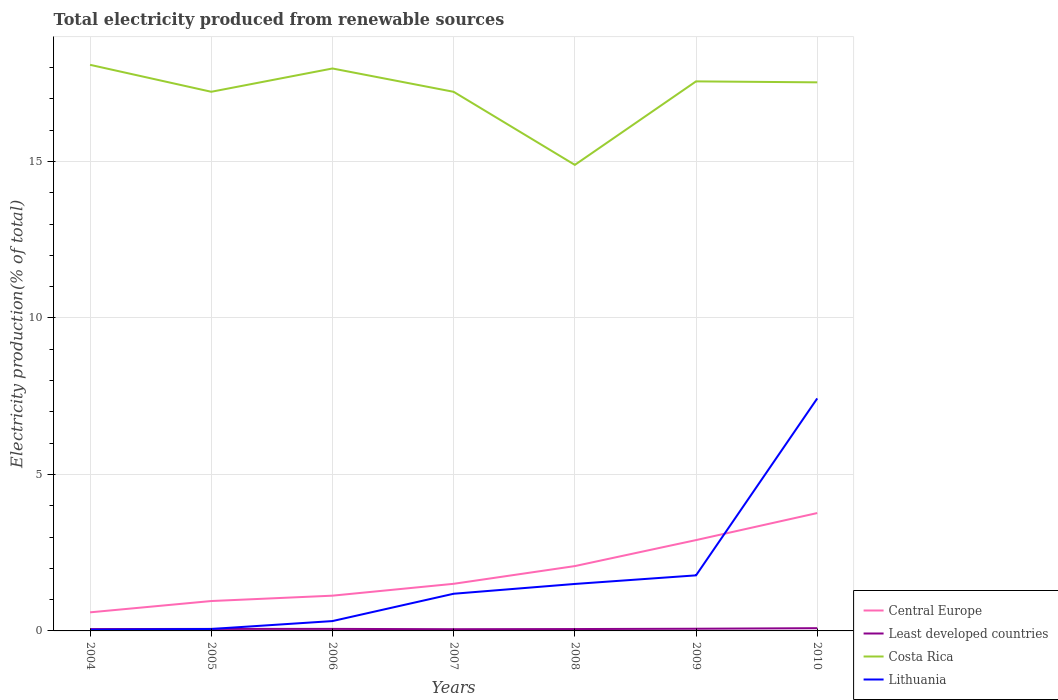How many different coloured lines are there?
Provide a succinct answer. 4. Across all years, what is the maximum total electricity produced in Lithuania?
Give a very brief answer. 0.04. In which year was the total electricity produced in Lithuania maximum?
Make the answer very short. 2004. What is the total total electricity produced in Lithuania in the graph?
Keep it short and to the point. -1.19. What is the difference between the highest and the second highest total electricity produced in Lithuania?
Keep it short and to the point. 7.39. What is the difference between the highest and the lowest total electricity produced in Least developed countries?
Your response must be concise. 2. How many lines are there?
Provide a succinct answer. 4. Are the values on the major ticks of Y-axis written in scientific E-notation?
Provide a short and direct response. No. Does the graph contain any zero values?
Offer a very short reply. No. Where does the legend appear in the graph?
Keep it short and to the point. Bottom right. How many legend labels are there?
Ensure brevity in your answer.  4. How are the legend labels stacked?
Offer a very short reply. Vertical. What is the title of the graph?
Provide a short and direct response. Total electricity produced from renewable sources. Does "Argentina" appear as one of the legend labels in the graph?
Offer a terse response. No. What is the label or title of the Y-axis?
Keep it short and to the point. Electricity production(% of total). What is the Electricity production(% of total) in Central Europe in 2004?
Make the answer very short. 0.59. What is the Electricity production(% of total) in Least developed countries in 2004?
Offer a very short reply. 0.06. What is the Electricity production(% of total) in Costa Rica in 2004?
Offer a terse response. 18.09. What is the Electricity production(% of total) in Lithuania in 2004?
Ensure brevity in your answer.  0.04. What is the Electricity production(% of total) in Central Europe in 2005?
Ensure brevity in your answer.  0.96. What is the Electricity production(% of total) in Least developed countries in 2005?
Give a very brief answer. 0.06. What is the Electricity production(% of total) in Costa Rica in 2005?
Offer a very short reply. 17.23. What is the Electricity production(% of total) in Lithuania in 2005?
Provide a succinct answer. 0.06. What is the Electricity production(% of total) in Central Europe in 2006?
Offer a terse response. 1.13. What is the Electricity production(% of total) of Least developed countries in 2006?
Your answer should be very brief. 0.06. What is the Electricity production(% of total) in Costa Rica in 2006?
Provide a short and direct response. 17.97. What is the Electricity production(% of total) in Lithuania in 2006?
Offer a terse response. 0.31. What is the Electricity production(% of total) of Central Europe in 2007?
Provide a short and direct response. 1.51. What is the Electricity production(% of total) of Least developed countries in 2007?
Your answer should be compact. 0.05. What is the Electricity production(% of total) in Costa Rica in 2007?
Give a very brief answer. 17.23. What is the Electricity production(% of total) in Lithuania in 2007?
Your response must be concise. 1.19. What is the Electricity production(% of total) in Central Europe in 2008?
Ensure brevity in your answer.  2.07. What is the Electricity production(% of total) of Least developed countries in 2008?
Provide a short and direct response. 0.06. What is the Electricity production(% of total) of Costa Rica in 2008?
Keep it short and to the point. 14.89. What is the Electricity production(% of total) in Lithuania in 2008?
Your response must be concise. 1.5. What is the Electricity production(% of total) of Central Europe in 2009?
Offer a very short reply. 2.9. What is the Electricity production(% of total) in Least developed countries in 2009?
Your answer should be compact. 0.07. What is the Electricity production(% of total) of Costa Rica in 2009?
Offer a terse response. 17.56. What is the Electricity production(% of total) in Lithuania in 2009?
Your answer should be compact. 1.78. What is the Electricity production(% of total) in Central Europe in 2010?
Make the answer very short. 3.77. What is the Electricity production(% of total) in Least developed countries in 2010?
Offer a terse response. 0.09. What is the Electricity production(% of total) of Costa Rica in 2010?
Your answer should be compact. 17.53. What is the Electricity production(% of total) in Lithuania in 2010?
Provide a short and direct response. 7.43. Across all years, what is the maximum Electricity production(% of total) in Central Europe?
Your response must be concise. 3.77. Across all years, what is the maximum Electricity production(% of total) in Least developed countries?
Keep it short and to the point. 0.09. Across all years, what is the maximum Electricity production(% of total) in Costa Rica?
Ensure brevity in your answer.  18.09. Across all years, what is the maximum Electricity production(% of total) of Lithuania?
Provide a succinct answer. 7.43. Across all years, what is the minimum Electricity production(% of total) in Central Europe?
Your response must be concise. 0.59. Across all years, what is the minimum Electricity production(% of total) in Least developed countries?
Ensure brevity in your answer.  0.05. Across all years, what is the minimum Electricity production(% of total) of Costa Rica?
Offer a terse response. 14.89. Across all years, what is the minimum Electricity production(% of total) of Lithuania?
Make the answer very short. 0.04. What is the total Electricity production(% of total) of Central Europe in the graph?
Make the answer very short. 12.92. What is the total Electricity production(% of total) of Least developed countries in the graph?
Your response must be concise. 0.46. What is the total Electricity production(% of total) in Costa Rica in the graph?
Your response must be concise. 120.5. What is the total Electricity production(% of total) of Lithuania in the graph?
Your answer should be very brief. 12.31. What is the difference between the Electricity production(% of total) of Central Europe in 2004 and that in 2005?
Make the answer very short. -0.36. What is the difference between the Electricity production(% of total) in Least developed countries in 2004 and that in 2005?
Make the answer very short. -0. What is the difference between the Electricity production(% of total) in Costa Rica in 2004 and that in 2005?
Make the answer very short. 0.86. What is the difference between the Electricity production(% of total) of Lithuania in 2004 and that in 2005?
Provide a short and direct response. -0.03. What is the difference between the Electricity production(% of total) of Central Europe in 2004 and that in 2006?
Offer a terse response. -0.53. What is the difference between the Electricity production(% of total) in Least developed countries in 2004 and that in 2006?
Provide a succinct answer. -0.01. What is the difference between the Electricity production(% of total) in Costa Rica in 2004 and that in 2006?
Provide a succinct answer. 0.12. What is the difference between the Electricity production(% of total) of Lithuania in 2004 and that in 2006?
Your answer should be compact. -0.28. What is the difference between the Electricity production(% of total) of Central Europe in 2004 and that in 2007?
Give a very brief answer. -0.91. What is the difference between the Electricity production(% of total) in Least developed countries in 2004 and that in 2007?
Provide a short and direct response. 0. What is the difference between the Electricity production(% of total) of Costa Rica in 2004 and that in 2007?
Your answer should be compact. 0.86. What is the difference between the Electricity production(% of total) of Lithuania in 2004 and that in 2007?
Keep it short and to the point. -1.15. What is the difference between the Electricity production(% of total) in Central Europe in 2004 and that in 2008?
Keep it short and to the point. -1.48. What is the difference between the Electricity production(% of total) in Least developed countries in 2004 and that in 2008?
Provide a succinct answer. -0. What is the difference between the Electricity production(% of total) of Costa Rica in 2004 and that in 2008?
Offer a very short reply. 3.2. What is the difference between the Electricity production(% of total) in Lithuania in 2004 and that in 2008?
Offer a terse response. -1.46. What is the difference between the Electricity production(% of total) of Central Europe in 2004 and that in 2009?
Provide a short and direct response. -2.31. What is the difference between the Electricity production(% of total) of Least developed countries in 2004 and that in 2009?
Offer a very short reply. -0.01. What is the difference between the Electricity production(% of total) in Costa Rica in 2004 and that in 2009?
Your answer should be very brief. 0.53. What is the difference between the Electricity production(% of total) of Lithuania in 2004 and that in 2009?
Offer a very short reply. -1.74. What is the difference between the Electricity production(% of total) in Central Europe in 2004 and that in 2010?
Your answer should be very brief. -3.17. What is the difference between the Electricity production(% of total) of Least developed countries in 2004 and that in 2010?
Your answer should be very brief. -0.03. What is the difference between the Electricity production(% of total) of Costa Rica in 2004 and that in 2010?
Offer a terse response. 0.56. What is the difference between the Electricity production(% of total) in Lithuania in 2004 and that in 2010?
Offer a very short reply. -7.39. What is the difference between the Electricity production(% of total) of Central Europe in 2005 and that in 2006?
Provide a succinct answer. -0.17. What is the difference between the Electricity production(% of total) of Least developed countries in 2005 and that in 2006?
Your answer should be compact. -0. What is the difference between the Electricity production(% of total) of Costa Rica in 2005 and that in 2006?
Offer a very short reply. -0.74. What is the difference between the Electricity production(% of total) of Lithuania in 2005 and that in 2006?
Provide a succinct answer. -0.25. What is the difference between the Electricity production(% of total) of Central Europe in 2005 and that in 2007?
Make the answer very short. -0.55. What is the difference between the Electricity production(% of total) of Least developed countries in 2005 and that in 2007?
Offer a terse response. 0.01. What is the difference between the Electricity production(% of total) of Costa Rica in 2005 and that in 2007?
Offer a terse response. 0. What is the difference between the Electricity production(% of total) in Lithuania in 2005 and that in 2007?
Your answer should be compact. -1.13. What is the difference between the Electricity production(% of total) of Central Europe in 2005 and that in 2008?
Make the answer very short. -1.12. What is the difference between the Electricity production(% of total) in Least developed countries in 2005 and that in 2008?
Offer a terse response. 0. What is the difference between the Electricity production(% of total) of Costa Rica in 2005 and that in 2008?
Make the answer very short. 2.34. What is the difference between the Electricity production(% of total) of Lithuania in 2005 and that in 2008?
Offer a terse response. -1.44. What is the difference between the Electricity production(% of total) of Central Europe in 2005 and that in 2009?
Your answer should be very brief. -1.95. What is the difference between the Electricity production(% of total) of Least developed countries in 2005 and that in 2009?
Your answer should be compact. -0.01. What is the difference between the Electricity production(% of total) of Costa Rica in 2005 and that in 2009?
Give a very brief answer. -0.33. What is the difference between the Electricity production(% of total) in Lithuania in 2005 and that in 2009?
Your answer should be compact. -1.71. What is the difference between the Electricity production(% of total) of Central Europe in 2005 and that in 2010?
Ensure brevity in your answer.  -2.81. What is the difference between the Electricity production(% of total) of Least developed countries in 2005 and that in 2010?
Make the answer very short. -0.02. What is the difference between the Electricity production(% of total) in Costa Rica in 2005 and that in 2010?
Offer a very short reply. -0.3. What is the difference between the Electricity production(% of total) in Lithuania in 2005 and that in 2010?
Offer a terse response. -7.37. What is the difference between the Electricity production(% of total) of Central Europe in 2006 and that in 2007?
Give a very brief answer. -0.38. What is the difference between the Electricity production(% of total) in Least developed countries in 2006 and that in 2007?
Make the answer very short. 0.01. What is the difference between the Electricity production(% of total) in Costa Rica in 2006 and that in 2007?
Ensure brevity in your answer.  0.75. What is the difference between the Electricity production(% of total) in Lithuania in 2006 and that in 2007?
Offer a terse response. -0.87. What is the difference between the Electricity production(% of total) in Central Europe in 2006 and that in 2008?
Offer a very short reply. -0.95. What is the difference between the Electricity production(% of total) in Least developed countries in 2006 and that in 2008?
Offer a very short reply. 0.01. What is the difference between the Electricity production(% of total) in Costa Rica in 2006 and that in 2008?
Your answer should be compact. 3.08. What is the difference between the Electricity production(% of total) in Lithuania in 2006 and that in 2008?
Your answer should be very brief. -1.19. What is the difference between the Electricity production(% of total) of Central Europe in 2006 and that in 2009?
Give a very brief answer. -1.78. What is the difference between the Electricity production(% of total) of Least developed countries in 2006 and that in 2009?
Offer a terse response. -0.01. What is the difference between the Electricity production(% of total) of Costa Rica in 2006 and that in 2009?
Give a very brief answer. 0.41. What is the difference between the Electricity production(% of total) in Lithuania in 2006 and that in 2009?
Ensure brevity in your answer.  -1.46. What is the difference between the Electricity production(% of total) in Central Europe in 2006 and that in 2010?
Your response must be concise. -2.64. What is the difference between the Electricity production(% of total) of Least developed countries in 2006 and that in 2010?
Your answer should be compact. -0.02. What is the difference between the Electricity production(% of total) of Costa Rica in 2006 and that in 2010?
Your answer should be compact. 0.44. What is the difference between the Electricity production(% of total) in Lithuania in 2006 and that in 2010?
Provide a succinct answer. -7.11. What is the difference between the Electricity production(% of total) of Central Europe in 2007 and that in 2008?
Provide a short and direct response. -0.57. What is the difference between the Electricity production(% of total) in Least developed countries in 2007 and that in 2008?
Your answer should be very brief. -0. What is the difference between the Electricity production(% of total) in Costa Rica in 2007 and that in 2008?
Keep it short and to the point. 2.33. What is the difference between the Electricity production(% of total) in Lithuania in 2007 and that in 2008?
Make the answer very short. -0.31. What is the difference between the Electricity production(% of total) in Central Europe in 2007 and that in 2009?
Offer a very short reply. -1.4. What is the difference between the Electricity production(% of total) in Least developed countries in 2007 and that in 2009?
Ensure brevity in your answer.  -0.01. What is the difference between the Electricity production(% of total) of Costa Rica in 2007 and that in 2009?
Keep it short and to the point. -0.33. What is the difference between the Electricity production(% of total) in Lithuania in 2007 and that in 2009?
Give a very brief answer. -0.59. What is the difference between the Electricity production(% of total) of Central Europe in 2007 and that in 2010?
Your response must be concise. -2.26. What is the difference between the Electricity production(% of total) of Least developed countries in 2007 and that in 2010?
Your answer should be compact. -0.03. What is the difference between the Electricity production(% of total) in Costa Rica in 2007 and that in 2010?
Provide a short and direct response. -0.3. What is the difference between the Electricity production(% of total) in Lithuania in 2007 and that in 2010?
Provide a succinct answer. -6.24. What is the difference between the Electricity production(% of total) in Central Europe in 2008 and that in 2009?
Provide a short and direct response. -0.83. What is the difference between the Electricity production(% of total) in Least developed countries in 2008 and that in 2009?
Provide a short and direct response. -0.01. What is the difference between the Electricity production(% of total) of Costa Rica in 2008 and that in 2009?
Offer a terse response. -2.67. What is the difference between the Electricity production(% of total) in Lithuania in 2008 and that in 2009?
Offer a very short reply. -0.27. What is the difference between the Electricity production(% of total) of Central Europe in 2008 and that in 2010?
Your answer should be compact. -1.69. What is the difference between the Electricity production(% of total) in Least developed countries in 2008 and that in 2010?
Ensure brevity in your answer.  -0.03. What is the difference between the Electricity production(% of total) of Costa Rica in 2008 and that in 2010?
Make the answer very short. -2.64. What is the difference between the Electricity production(% of total) of Lithuania in 2008 and that in 2010?
Your answer should be very brief. -5.93. What is the difference between the Electricity production(% of total) of Central Europe in 2009 and that in 2010?
Your answer should be compact. -0.86. What is the difference between the Electricity production(% of total) in Least developed countries in 2009 and that in 2010?
Offer a terse response. -0.02. What is the difference between the Electricity production(% of total) of Costa Rica in 2009 and that in 2010?
Your answer should be compact. 0.03. What is the difference between the Electricity production(% of total) in Lithuania in 2009 and that in 2010?
Your answer should be very brief. -5.65. What is the difference between the Electricity production(% of total) in Central Europe in 2004 and the Electricity production(% of total) in Least developed countries in 2005?
Your response must be concise. 0.53. What is the difference between the Electricity production(% of total) of Central Europe in 2004 and the Electricity production(% of total) of Costa Rica in 2005?
Make the answer very short. -16.63. What is the difference between the Electricity production(% of total) in Central Europe in 2004 and the Electricity production(% of total) in Lithuania in 2005?
Keep it short and to the point. 0.53. What is the difference between the Electricity production(% of total) of Least developed countries in 2004 and the Electricity production(% of total) of Costa Rica in 2005?
Offer a very short reply. -17.17. What is the difference between the Electricity production(% of total) of Least developed countries in 2004 and the Electricity production(% of total) of Lithuania in 2005?
Provide a short and direct response. -0. What is the difference between the Electricity production(% of total) in Costa Rica in 2004 and the Electricity production(% of total) in Lithuania in 2005?
Ensure brevity in your answer.  18.03. What is the difference between the Electricity production(% of total) in Central Europe in 2004 and the Electricity production(% of total) in Least developed countries in 2006?
Offer a very short reply. 0.53. What is the difference between the Electricity production(% of total) of Central Europe in 2004 and the Electricity production(% of total) of Costa Rica in 2006?
Provide a succinct answer. -17.38. What is the difference between the Electricity production(% of total) of Central Europe in 2004 and the Electricity production(% of total) of Lithuania in 2006?
Give a very brief answer. 0.28. What is the difference between the Electricity production(% of total) of Least developed countries in 2004 and the Electricity production(% of total) of Costa Rica in 2006?
Keep it short and to the point. -17.91. What is the difference between the Electricity production(% of total) of Least developed countries in 2004 and the Electricity production(% of total) of Lithuania in 2006?
Your answer should be compact. -0.26. What is the difference between the Electricity production(% of total) of Costa Rica in 2004 and the Electricity production(% of total) of Lithuania in 2006?
Keep it short and to the point. 17.77. What is the difference between the Electricity production(% of total) in Central Europe in 2004 and the Electricity production(% of total) in Least developed countries in 2007?
Give a very brief answer. 0.54. What is the difference between the Electricity production(% of total) of Central Europe in 2004 and the Electricity production(% of total) of Costa Rica in 2007?
Your answer should be compact. -16.63. What is the difference between the Electricity production(% of total) in Central Europe in 2004 and the Electricity production(% of total) in Lithuania in 2007?
Offer a terse response. -0.59. What is the difference between the Electricity production(% of total) in Least developed countries in 2004 and the Electricity production(% of total) in Costa Rica in 2007?
Keep it short and to the point. -17.17. What is the difference between the Electricity production(% of total) of Least developed countries in 2004 and the Electricity production(% of total) of Lithuania in 2007?
Provide a succinct answer. -1.13. What is the difference between the Electricity production(% of total) of Costa Rica in 2004 and the Electricity production(% of total) of Lithuania in 2007?
Give a very brief answer. 16.9. What is the difference between the Electricity production(% of total) of Central Europe in 2004 and the Electricity production(% of total) of Least developed countries in 2008?
Keep it short and to the point. 0.53. What is the difference between the Electricity production(% of total) in Central Europe in 2004 and the Electricity production(% of total) in Costa Rica in 2008?
Ensure brevity in your answer.  -14.3. What is the difference between the Electricity production(% of total) in Central Europe in 2004 and the Electricity production(% of total) in Lithuania in 2008?
Give a very brief answer. -0.91. What is the difference between the Electricity production(% of total) of Least developed countries in 2004 and the Electricity production(% of total) of Costa Rica in 2008?
Provide a succinct answer. -14.83. What is the difference between the Electricity production(% of total) of Least developed countries in 2004 and the Electricity production(% of total) of Lithuania in 2008?
Offer a terse response. -1.44. What is the difference between the Electricity production(% of total) of Costa Rica in 2004 and the Electricity production(% of total) of Lithuania in 2008?
Provide a short and direct response. 16.59. What is the difference between the Electricity production(% of total) in Central Europe in 2004 and the Electricity production(% of total) in Least developed countries in 2009?
Offer a very short reply. 0.52. What is the difference between the Electricity production(% of total) in Central Europe in 2004 and the Electricity production(% of total) in Costa Rica in 2009?
Give a very brief answer. -16.97. What is the difference between the Electricity production(% of total) in Central Europe in 2004 and the Electricity production(% of total) in Lithuania in 2009?
Give a very brief answer. -1.18. What is the difference between the Electricity production(% of total) of Least developed countries in 2004 and the Electricity production(% of total) of Costa Rica in 2009?
Keep it short and to the point. -17.5. What is the difference between the Electricity production(% of total) in Least developed countries in 2004 and the Electricity production(% of total) in Lithuania in 2009?
Your answer should be compact. -1.72. What is the difference between the Electricity production(% of total) of Costa Rica in 2004 and the Electricity production(% of total) of Lithuania in 2009?
Offer a terse response. 16.31. What is the difference between the Electricity production(% of total) in Central Europe in 2004 and the Electricity production(% of total) in Least developed countries in 2010?
Provide a succinct answer. 0.51. What is the difference between the Electricity production(% of total) of Central Europe in 2004 and the Electricity production(% of total) of Costa Rica in 2010?
Provide a succinct answer. -16.94. What is the difference between the Electricity production(% of total) of Central Europe in 2004 and the Electricity production(% of total) of Lithuania in 2010?
Give a very brief answer. -6.83. What is the difference between the Electricity production(% of total) in Least developed countries in 2004 and the Electricity production(% of total) in Costa Rica in 2010?
Offer a very short reply. -17.47. What is the difference between the Electricity production(% of total) of Least developed countries in 2004 and the Electricity production(% of total) of Lithuania in 2010?
Keep it short and to the point. -7.37. What is the difference between the Electricity production(% of total) in Costa Rica in 2004 and the Electricity production(% of total) in Lithuania in 2010?
Provide a short and direct response. 10.66. What is the difference between the Electricity production(% of total) in Central Europe in 2005 and the Electricity production(% of total) in Least developed countries in 2006?
Keep it short and to the point. 0.89. What is the difference between the Electricity production(% of total) in Central Europe in 2005 and the Electricity production(% of total) in Costa Rica in 2006?
Your response must be concise. -17.02. What is the difference between the Electricity production(% of total) of Central Europe in 2005 and the Electricity production(% of total) of Lithuania in 2006?
Offer a terse response. 0.64. What is the difference between the Electricity production(% of total) in Least developed countries in 2005 and the Electricity production(% of total) in Costa Rica in 2006?
Your answer should be very brief. -17.91. What is the difference between the Electricity production(% of total) in Least developed countries in 2005 and the Electricity production(% of total) in Lithuania in 2006?
Offer a very short reply. -0.25. What is the difference between the Electricity production(% of total) in Costa Rica in 2005 and the Electricity production(% of total) in Lithuania in 2006?
Your response must be concise. 16.91. What is the difference between the Electricity production(% of total) in Central Europe in 2005 and the Electricity production(% of total) in Least developed countries in 2007?
Give a very brief answer. 0.9. What is the difference between the Electricity production(% of total) in Central Europe in 2005 and the Electricity production(% of total) in Costa Rica in 2007?
Your answer should be compact. -16.27. What is the difference between the Electricity production(% of total) in Central Europe in 2005 and the Electricity production(% of total) in Lithuania in 2007?
Give a very brief answer. -0.23. What is the difference between the Electricity production(% of total) of Least developed countries in 2005 and the Electricity production(% of total) of Costa Rica in 2007?
Offer a very short reply. -17.16. What is the difference between the Electricity production(% of total) in Least developed countries in 2005 and the Electricity production(% of total) in Lithuania in 2007?
Provide a succinct answer. -1.12. What is the difference between the Electricity production(% of total) in Costa Rica in 2005 and the Electricity production(% of total) in Lithuania in 2007?
Keep it short and to the point. 16.04. What is the difference between the Electricity production(% of total) in Central Europe in 2005 and the Electricity production(% of total) in Least developed countries in 2008?
Ensure brevity in your answer.  0.9. What is the difference between the Electricity production(% of total) in Central Europe in 2005 and the Electricity production(% of total) in Costa Rica in 2008?
Provide a succinct answer. -13.94. What is the difference between the Electricity production(% of total) of Central Europe in 2005 and the Electricity production(% of total) of Lithuania in 2008?
Offer a very short reply. -0.55. What is the difference between the Electricity production(% of total) in Least developed countries in 2005 and the Electricity production(% of total) in Costa Rica in 2008?
Your answer should be compact. -14.83. What is the difference between the Electricity production(% of total) of Least developed countries in 2005 and the Electricity production(% of total) of Lithuania in 2008?
Offer a terse response. -1.44. What is the difference between the Electricity production(% of total) in Costa Rica in 2005 and the Electricity production(% of total) in Lithuania in 2008?
Make the answer very short. 15.73. What is the difference between the Electricity production(% of total) in Central Europe in 2005 and the Electricity production(% of total) in Least developed countries in 2009?
Give a very brief answer. 0.89. What is the difference between the Electricity production(% of total) of Central Europe in 2005 and the Electricity production(% of total) of Costa Rica in 2009?
Make the answer very short. -16.6. What is the difference between the Electricity production(% of total) in Central Europe in 2005 and the Electricity production(% of total) in Lithuania in 2009?
Make the answer very short. -0.82. What is the difference between the Electricity production(% of total) of Least developed countries in 2005 and the Electricity production(% of total) of Costa Rica in 2009?
Provide a succinct answer. -17.5. What is the difference between the Electricity production(% of total) of Least developed countries in 2005 and the Electricity production(% of total) of Lithuania in 2009?
Ensure brevity in your answer.  -1.71. What is the difference between the Electricity production(% of total) of Costa Rica in 2005 and the Electricity production(% of total) of Lithuania in 2009?
Keep it short and to the point. 15.45. What is the difference between the Electricity production(% of total) in Central Europe in 2005 and the Electricity production(% of total) in Least developed countries in 2010?
Your response must be concise. 0.87. What is the difference between the Electricity production(% of total) in Central Europe in 2005 and the Electricity production(% of total) in Costa Rica in 2010?
Your answer should be very brief. -16.57. What is the difference between the Electricity production(% of total) in Central Europe in 2005 and the Electricity production(% of total) in Lithuania in 2010?
Provide a short and direct response. -6.47. What is the difference between the Electricity production(% of total) of Least developed countries in 2005 and the Electricity production(% of total) of Costa Rica in 2010?
Make the answer very short. -17.47. What is the difference between the Electricity production(% of total) in Least developed countries in 2005 and the Electricity production(% of total) in Lithuania in 2010?
Your answer should be very brief. -7.37. What is the difference between the Electricity production(% of total) of Costa Rica in 2005 and the Electricity production(% of total) of Lithuania in 2010?
Ensure brevity in your answer.  9.8. What is the difference between the Electricity production(% of total) of Central Europe in 2006 and the Electricity production(% of total) of Least developed countries in 2007?
Ensure brevity in your answer.  1.07. What is the difference between the Electricity production(% of total) of Central Europe in 2006 and the Electricity production(% of total) of Costa Rica in 2007?
Offer a terse response. -16.1. What is the difference between the Electricity production(% of total) in Central Europe in 2006 and the Electricity production(% of total) in Lithuania in 2007?
Keep it short and to the point. -0.06. What is the difference between the Electricity production(% of total) of Least developed countries in 2006 and the Electricity production(% of total) of Costa Rica in 2007?
Your answer should be compact. -17.16. What is the difference between the Electricity production(% of total) of Least developed countries in 2006 and the Electricity production(% of total) of Lithuania in 2007?
Give a very brief answer. -1.12. What is the difference between the Electricity production(% of total) of Costa Rica in 2006 and the Electricity production(% of total) of Lithuania in 2007?
Ensure brevity in your answer.  16.78. What is the difference between the Electricity production(% of total) of Central Europe in 2006 and the Electricity production(% of total) of Least developed countries in 2008?
Your answer should be compact. 1.07. What is the difference between the Electricity production(% of total) of Central Europe in 2006 and the Electricity production(% of total) of Costa Rica in 2008?
Offer a very short reply. -13.77. What is the difference between the Electricity production(% of total) in Central Europe in 2006 and the Electricity production(% of total) in Lithuania in 2008?
Your answer should be very brief. -0.37. What is the difference between the Electricity production(% of total) in Least developed countries in 2006 and the Electricity production(% of total) in Costa Rica in 2008?
Your answer should be compact. -14.83. What is the difference between the Electricity production(% of total) in Least developed countries in 2006 and the Electricity production(% of total) in Lithuania in 2008?
Give a very brief answer. -1.44. What is the difference between the Electricity production(% of total) in Costa Rica in 2006 and the Electricity production(% of total) in Lithuania in 2008?
Your answer should be compact. 16.47. What is the difference between the Electricity production(% of total) of Central Europe in 2006 and the Electricity production(% of total) of Least developed countries in 2009?
Keep it short and to the point. 1.06. What is the difference between the Electricity production(% of total) of Central Europe in 2006 and the Electricity production(% of total) of Costa Rica in 2009?
Provide a short and direct response. -16.43. What is the difference between the Electricity production(% of total) of Central Europe in 2006 and the Electricity production(% of total) of Lithuania in 2009?
Your answer should be very brief. -0.65. What is the difference between the Electricity production(% of total) of Least developed countries in 2006 and the Electricity production(% of total) of Costa Rica in 2009?
Provide a succinct answer. -17.5. What is the difference between the Electricity production(% of total) of Least developed countries in 2006 and the Electricity production(% of total) of Lithuania in 2009?
Your answer should be compact. -1.71. What is the difference between the Electricity production(% of total) of Costa Rica in 2006 and the Electricity production(% of total) of Lithuania in 2009?
Make the answer very short. 16.2. What is the difference between the Electricity production(% of total) in Central Europe in 2006 and the Electricity production(% of total) in Least developed countries in 2010?
Ensure brevity in your answer.  1.04. What is the difference between the Electricity production(% of total) in Central Europe in 2006 and the Electricity production(% of total) in Costa Rica in 2010?
Offer a terse response. -16.4. What is the difference between the Electricity production(% of total) of Central Europe in 2006 and the Electricity production(% of total) of Lithuania in 2010?
Your answer should be compact. -6.3. What is the difference between the Electricity production(% of total) of Least developed countries in 2006 and the Electricity production(% of total) of Costa Rica in 2010?
Keep it short and to the point. -17.46. What is the difference between the Electricity production(% of total) in Least developed countries in 2006 and the Electricity production(% of total) in Lithuania in 2010?
Your response must be concise. -7.36. What is the difference between the Electricity production(% of total) in Costa Rica in 2006 and the Electricity production(% of total) in Lithuania in 2010?
Keep it short and to the point. 10.54. What is the difference between the Electricity production(% of total) of Central Europe in 2007 and the Electricity production(% of total) of Least developed countries in 2008?
Keep it short and to the point. 1.45. What is the difference between the Electricity production(% of total) of Central Europe in 2007 and the Electricity production(% of total) of Costa Rica in 2008?
Your response must be concise. -13.39. What is the difference between the Electricity production(% of total) in Central Europe in 2007 and the Electricity production(% of total) in Lithuania in 2008?
Provide a succinct answer. 0. What is the difference between the Electricity production(% of total) in Least developed countries in 2007 and the Electricity production(% of total) in Costa Rica in 2008?
Your response must be concise. -14.84. What is the difference between the Electricity production(% of total) in Least developed countries in 2007 and the Electricity production(% of total) in Lithuania in 2008?
Provide a short and direct response. -1.45. What is the difference between the Electricity production(% of total) of Costa Rica in 2007 and the Electricity production(% of total) of Lithuania in 2008?
Give a very brief answer. 15.73. What is the difference between the Electricity production(% of total) in Central Europe in 2007 and the Electricity production(% of total) in Least developed countries in 2009?
Your response must be concise. 1.44. What is the difference between the Electricity production(% of total) in Central Europe in 2007 and the Electricity production(% of total) in Costa Rica in 2009?
Ensure brevity in your answer.  -16.05. What is the difference between the Electricity production(% of total) of Central Europe in 2007 and the Electricity production(% of total) of Lithuania in 2009?
Give a very brief answer. -0.27. What is the difference between the Electricity production(% of total) of Least developed countries in 2007 and the Electricity production(% of total) of Costa Rica in 2009?
Give a very brief answer. -17.5. What is the difference between the Electricity production(% of total) of Least developed countries in 2007 and the Electricity production(% of total) of Lithuania in 2009?
Your answer should be very brief. -1.72. What is the difference between the Electricity production(% of total) in Costa Rica in 2007 and the Electricity production(% of total) in Lithuania in 2009?
Your answer should be compact. 15.45. What is the difference between the Electricity production(% of total) in Central Europe in 2007 and the Electricity production(% of total) in Least developed countries in 2010?
Make the answer very short. 1.42. What is the difference between the Electricity production(% of total) in Central Europe in 2007 and the Electricity production(% of total) in Costa Rica in 2010?
Keep it short and to the point. -16.02. What is the difference between the Electricity production(% of total) in Central Europe in 2007 and the Electricity production(% of total) in Lithuania in 2010?
Offer a terse response. -5.92. What is the difference between the Electricity production(% of total) in Least developed countries in 2007 and the Electricity production(% of total) in Costa Rica in 2010?
Give a very brief answer. -17.47. What is the difference between the Electricity production(% of total) of Least developed countries in 2007 and the Electricity production(% of total) of Lithuania in 2010?
Provide a succinct answer. -7.37. What is the difference between the Electricity production(% of total) of Costa Rica in 2007 and the Electricity production(% of total) of Lithuania in 2010?
Your answer should be very brief. 9.8. What is the difference between the Electricity production(% of total) of Central Europe in 2008 and the Electricity production(% of total) of Least developed countries in 2009?
Make the answer very short. 2. What is the difference between the Electricity production(% of total) of Central Europe in 2008 and the Electricity production(% of total) of Costa Rica in 2009?
Ensure brevity in your answer.  -15.49. What is the difference between the Electricity production(% of total) of Central Europe in 2008 and the Electricity production(% of total) of Lithuania in 2009?
Offer a very short reply. 0.3. What is the difference between the Electricity production(% of total) of Least developed countries in 2008 and the Electricity production(% of total) of Costa Rica in 2009?
Provide a short and direct response. -17.5. What is the difference between the Electricity production(% of total) of Least developed countries in 2008 and the Electricity production(% of total) of Lithuania in 2009?
Your response must be concise. -1.72. What is the difference between the Electricity production(% of total) of Costa Rica in 2008 and the Electricity production(% of total) of Lithuania in 2009?
Your response must be concise. 13.12. What is the difference between the Electricity production(% of total) in Central Europe in 2008 and the Electricity production(% of total) in Least developed countries in 2010?
Provide a short and direct response. 1.98. What is the difference between the Electricity production(% of total) of Central Europe in 2008 and the Electricity production(% of total) of Costa Rica in 2010?
Make the answer very short. -15.46. What is the difference between the Electricity production(% of total) of Central Europe in 2008 and the Electricity production(% of total) of Lithuania in 2010?
Your answer should be very brief. -5.36. What is the difference between the Electricity production(% of total) in Least developed countries in 2008 and the Electricity production(% of total) in Costa Rica in 2010?
Ensure brevity in your answer.  -17.47. What is the difference between the Electricity production(% of total) of Least developed countries in 2008 and the Electricity production(% of total) of Lithuania in 2010?
Give a very brief answer. -7.37. What is the difference between the Electricity production(% of total) in Costa Rica in 2008 and the Electricity production(% of total) in Lithuania in 2010?
Offer a terse response. 7.46. What is the difference between the Electricity production(% of total) of Central Europe in 2009 and the Electricity production(% of total) of Least developed countries in 2010?
Your answer should be compact. 2.82. What is the difference between the Electricity production(% of total) of Central Europe in 2009 and the Electricity production(% of total) of Costa Rica in 2010?
Your answer should be very brief. -14.63. What is the difference between the Electricity production(% of total) of Central Europe in 2009 and the Electricity production(% of total) of Lithuania in 2010?
Your answer should be compact. -4.53. What is the difference between the Electricity production(% of total) of Least developed countries in 2009 and the Electricity production(% of total) of Costa Rica in 2010?
Your answer should be compact. -17.46. What is the difference between the Electricity production(% of total) of Least developed countries in 2009 and the Electricity production(% of total) of Lithuania in 2010?
Offer a terse response. -7.36. What is the difference between the Electricity production(% of total) in Costa Rica in 2009 and the Electricity production(% of total) in Lithuania in 2010?
Keep it short and to the point. 10.13. What is the average Electricity production(% of total) in Central Europe per year?
Give a very brief answer. 1.85. What is the average Electricity production(% of total) of Least developed countries per year?
Offer a terse response. 0.07. What is the average Electricity production(% of total) in Costa Rica per year?
Your answer should be compact. 17.21. What is the average Electricity production(% of total) in Lithuania per year?
Ensure brevity in your answer.  1.76. In the year 2004, what is the difference between the Electricity production(% of total) in Central Europe and Electricity production(% of total) in Least developed countries?
Your response must be concise. 0.54. In the year 2004, what is the difference between the Electricity production(% of total) in Central Europe and Electricity production(% of total) in Costa Rica?
Ensure brevity in your answer.  -17.5. In the year 2004, what is the difference between the Electricity production(% of total) in Central Europe and Electricity production(% of total) in Lithuania?
Provide a succinct answer. 0.56. In the year 2004, what is the difference between the Electricity production(% of total) of Least developed countries and Electricity production(% of total) of Costa Rica?
Offer a terse response. -18.03. In the year 2004, what is the difference between the Electricity production(% of total) in Least developed countries and Electricity production(% of total) in Lithuania?
Your response must be concise. 0.02. In the year 2004, what is the difference between the Electricity production(% of total) of Costa Rica and Electricity production(% of total) of Lithuania?
Provide a short and direct response. 18.05. In the year 2005, what is the difference between the Electricity production(% of total) in Central Europe and Electricity production(% of total) in Least developed countries?
Keep it short and to the point. 0.89. In the year 2005, what is the difference between the Electricity production(% of total) of Central Europe and Electricity production(% of total) of Costa Rica?
Provide a short and direct response. -16.27. In the year 2005, what is the difference between the Electricity production(% of total) in Central Europe and Electricity production(% of total) in Lithuania?
Your answer should be very brief. 0.89. In the year 2005, what is the difference between the Electricity production(% of total) in Least developed countries and Electricity production(% of total) in Costa Rica?
Offer a terse response. -17.16. In the year 2005, what is the difference between the Electricity production(% of total) in Least developed countries and Electricity production(% of total) in Lithuania?
Your answer should be very brief. 0. In the year 2005, what is the difference between the Electricity production(% of total) of Costa Rica and Electricity production(% of total) of Lithuania?
Your response must be concise. 17.17. In the year 2006, what is the difference between the Electricity production(% of total) in Central Europe and Electricity production(% of total) in Least developed countries?
Your response must be concise. 1.06. In the year 2006, what is the difference between the Electricity production(% of total) of Central Europe and Electricity production(% of total) of Costa Rica?
Your answer should be very brief. -16.85. In the year 2006, what is the difference between the Electricity production(% of total) in Central Europe and Electricity production(% of total) in Lithuania?
Your answer should be very brief. 0.81. In the year 2006, what is the difference between the Electricity production(% of total) of Least developed countries and Electricity production(% of total) of Costa Rica?
Your response must be concise. -17.91. In the year 2006, what is the difference between the Electricity production(% of total) in Least developed countries and Electricity production(% of total) in Lithuania?
Provide a succinct answer. -0.25. In the year 2006, what is the difference between the Electricity production(% of total) of Costa Rica and Electricity production(% of total) of Lithuania?
Ensure brevity in your answer.  17.66. In the year 2007, what is the difference between the Electricity production(% of total) in Central Europe and Electricity production(% of total) in Least developed countries?
Give a very brief answer. 1.45. In the year 2007, what is the difference between the Electricity production(% of total) of Central Europe and Electricity production(% of total) of Costa Rica?
Provide a short and direct response. -15.72. In the year 2007, what is the difference between the Electricity production(% of total) in Central Europe and Electricity production(% of total) in Lithuania?
Your answer should be very brief. 0.32. In the year 2007, what is the difference between the Electricity production(% of total) of Least developed countries and Electricity production(% of total) of Costa Rica?
Your answer should be very brief. -17.17. In the year 2007, what is the difference between the Electricity production(% of total) in Least developed countries and Electricity production(% of total) in Lithuania?
Your answer should be compact. -1.13. In the year 2007, what is the difference between the Electricity production(% of total) of Costa Rica and Electricity production(% of total) of Lithuania?
Your answer should be compact. 16.04. In the year 2008, what is the difference between the Electricity production(% of total) of Central Europe and Electricity production(% of total) of Least developed countries?
Your answer should be very brief. 2.01. In the year 2008, what is the difference between the Electricity production(% of total) of Central Europe and Electricity production(% of total) of Costa Rica?
Ensure brevity in your answer.  -12.82. In the year 2008, what is the difference between the Electricity production(% of total) of Central Europe and Electricity production(% of total) of Lithuania?
Keep it short and to the point. 0.57. In the year 2008, what is the difference between the Electricity production(% of total) of Least developed countries and Electricity production(% of total) of Costa Rica?
Offer a very short reply. -14.83. In the year 2008, what is the difference between the Electricity production(% of total) of Least developed countries and Electricity production(% of total) of Lithuania?
Your response must be concise. -1.44. In the year 2008, what is the difference between the Electricity production(% of total) of Costa Rica and Electricity production(% of total) of Lithuania?
Offer a very short reply. 13.39. In the year 2009, what is the difference between the Electricity production(% of total) in Central Europe and Electricity production(% of total) in Least developed countries?
Your answer should be compact. 2.83. In the year 2009, what is the difference between the Electricity production(% of total) in Central Europe and Electricity production(% of total) in Costa Rica?
Make the answer very short. -14.66. In the year 2009, what is the difference between the Electricity production(% of total) in Central Europe and Electricity production(% of total) in Lithuania?
Provide a short and direct response. 1.13. In the year 2009, what is the difference between the Electricity production(% of total) in Least developed countries and Electricity production(% of total) in Costa Rica?
Offer a terse response. -17.49. In the year 2009, what is the difference between the Electricity production(% of total) of Least developed countries and Electricity production(% of total) of Lithuania?
Your response must be concise. -1.71. In the year 2009, what is the difference between the Electricity production(% of total) of Costa Rica and Electricity production(% of total) of Lithuania?
Your answer should be compact. 15.78. In the year 2010, what is the difference between the Electricity production(% of total) of Central Europe and Electricity production(% of total) of Least developed countries?
Offer a very short reply. 3.68. In the year 2010, what is the difference between the Electricity production(% of total) in Central Europe and Electricity production(% of total) in Costa Rica?
Give a very brief answer. -13.76. In the year 2010, what is the difference between the Electricity production(% of total) of Central Europe and Electricity production(% of total) of Lithuania?
Offer a terse response. -3.66. In the year 2010, what is the difference between the Electricity production(% of total) in Least developed countries and Electricity production(% of total) in Costa Rica?
Ensure brevity in your answer.  -17.44. In the year 2010, what is the difference between the Electricity production(% of total) of Least developed countries and Electricity production(% of total) of Lithuania?
Provide a succinct answer. -7.34. In the year 2010, what is the difference between the Electricity production(% of total) of Costa Rica and Electricity production(% of total) of Lithuania?
Make the answer very short. 10.1. What is the ratio of the Electricity production(% of total) in Central Europe in 2004 to that in 2005?
Ensure brevity in your answer.  0.62. What is the ratio of the Electricity production(% of total) of Least developed countries in 2004 to that in 2005?
Keep it short and to the point. 0.92. What is the ratio of the Electricity production(% of total) of Lithuania in 2004 to that in 2005?
Provide a succinct answer. 0.6. What is the ratio of the Electricity production(% of total) of Central Europe in 2004 to that in 2006?
Give a very brief answer. 0.53. What is the ratio of the Electricity production(% of total) in Least developed countries in 2004 to that in 2006?
Give a very brief answer. 0.91. What is the ratio of the Electricity production(% of total) in Lithuania in 2004 to that in 2006?
Keep it short and to the point. 0.12. What is the ratio of the Electricity production(% of total) of Central Europe in 2004 to that in 2007?
Offer a very short reply. 0.39. What is the ratio of the Electricity production(% of total) of Least developed countries in 2004 to that in 2007?
Make the answer very short. 1.07. What is the ratio of the Electricity production(% of total) of Costa Rica in 2004 to that in 2007?
Your response must be concise. 1.05. What is the ratio of the Electricity production(% of total) in Lithuania in 2004 to that in 2007?
Ensure brevity in your answer.  0.03. What is the ratio of the Electricity production(% of total) in Central Europe in 2004 to that in 2008?
Give a very brief answer. 0.29. What is the ratio of the Electricity production(% of total) in Least developed countries in 2004 to that in 2008?
Provide a succinct answer. 0.99. What is the ratio of the Electricity production(% of total) in Costa Rica in 2004 to that in 2008?
Make the answer very short. 1.21. What is the ratio of the Electricity production(% of total) of Lithuania in 2004 to that in 2008?
Your answer should be very brief. 0.02. What is the ratio of the Electricity production(% of total) of Central Europe in 2004 to that in 2009?
Ensure brevity in your answer.  0.2. What is the ratio of the Electricity production(% of total) of Least developed countries in 2004 to that in 2009?
Your answer should be very brief. 0.84. What is the ratio of the Electricity production(% of total) in Costa Rica in 2004 to that in 2009?
Ensure brevity in your answer.  1.03. What is the ratio of the Electricity production(% of total) in Lithuania in 2004 to that in 2009?
Ensure brevity in your answer.  0.02. What is the ratio of the Electricity production(% of total) in Central Europe in 2004 to that in 2010?
Your answer should be compact. 0.16. What is the ratio of the Electricity production(% of total) in Least developed countries in 2004 to that in 2010?
Give a very brief answer. 0.67. What is the ratio of the Electricity production(% of total) of Costa Rica in 2004 to that in 2010?
Give a very brief answer. 1.03. What is the ratio of the Electricity production(% of total) of Lithuania in 2004 to that in 2010?
Your response must be concise. 0.01. What is the ratio of the Electricity production(% of total) in Central Europe in 2005 to that in 2006?
Make the answer very short. 0.85. What is the ratio of the Electricity production(% of total) in Least developed countries in 2005 to that in 2006?
Make the answer very short. 0.99. What is the ratio of the Electricity production(% of total) in Costa Rica in 2005 to that in 2006?
Provide a succinct answer. 0.96. What is the ratio of the Electricity production(% of total) in Lithuania in 2005 to that in 2006?
Your answer should be compact. 0.2. What is the ratio of the Electricity production(% of total) of Central Europe in 2005 to that in 2007?
Your answer should be compact. 0.63. What is the ratio of the Electricity production(% of total) in Least developed countries in 2005 to that in 2007?
Ensure brevity in your answer.  1.16. What is the ratio of the Electricity production(% of total) of Lithuania in 2005 to that in 2007?
Offer a terse response. 0.05. What is the ratio of the Electricity production(% of total) in Central Europe in 2005 to that in 2008?
Your response must be concise. 0.46. What is the ratio of the Electricity production(% of total) of Least developed countries in 2005 to that in 2008?
Provide a succinct answer. 1.07. What is the ratio of the Electricity production(% of total) in Costa Rica in 2005 to that in 2008?
Give a very brief answer. 1.16. What is the ratio of the Electricity production(% of total) of Lithuania in 2005 to that in 2008?
Your answer should be very brief. 0.04. What is the ratio of the Electricity production(% of total) of Central Europe in 2005 to that in 2009?
Offer a terse response. 0.33. What is the ratio of the Electricity production(% of total) in Least developed countries in 2005 to that in 2009?
Ensure brevity in your answer.  0.92. What is the ratio of the Electricity production(% of total) of Costa Rica in 2005 to that in 2009?
Offer a terse response. 0.98. What is the ratio of the Electricity production(% of total) of Lithuania in 2005 to that in 2009?
Ensure brevity in your answer.  0.04. What is the ratio of the Electricity production(% of total) in Central Europe in 2005 to that in 2010?
Provide a succinct answer. 0.25. What is the ratio of the Electricity production(% of total) of Least developed countries in 2005 to that in 2010?
Provide a succinct answer. 0.73. What is the ratio of the Electricity production(% of total) of Costa Rica in 2005 to that in 2010?
Your response must be concise. 0.98. What is the ratio of the Electricity production(% of total) of Lithuania in 2005 to that in 2010?
Make the answer very short. 0.01. What is the ratio of the Electricity production(% of total) of Central Europe in 2006 to that in 2007?
Make the answer very short. 0.75. What is the ratio of the Electricity production(% of total) in Least developed countries in 2006 to that in 2007?
Ensure brevity in your answer.  1.18. What is the ratio of the Electricity production(% of total) in Costa Rica in 2006 to that in 2007?
Keep it short and to the point. 1.04. What is the ratio of the Electricity production(% of total) in Lithuania in 2006 to that in 2007?
Your response must be concise. 0.26. What is the ratio of the Electricity production(% of total) in Central Europe in 2006 to that in 2008?
Give a very brief answer. 0.54. What is the ratio of the Electricity production(% of total) in Least developed countries in 2006 to that in 2008?
Provide a short and direct response. 1.08. What is the ratio of the Electricity production(% of total) in Costa Rica in 2006 to that in 2008?
Provide a short and direct response. 1.21. What is the ratio of the Electricity production(% of total) of Lithuania in 2006 to that in 2008?
Provide a short and direct response. 0.21. What is the ratio of the Electricity production(% of total) in Central Europe in 2006 to that in 2009?
Give a very brief answer. 0.39. What is the ratio of the Electricity production(% of total) in Least developed countries in 2006 to that in 2009?
Your answer should be very brief. 0.93. What is the ratio of the Electricity production(% of total) of Costa Rica in 2006 to that in 2009?
Give a very brief answer. 1.02. What is the ratio of the Electricity production(% of total) in Lithuania in 2006 to that in 2009?
Make the answer very short. 0.18. What is the ratio of the Electricity production(% of total) of Central Europe in 2006 to that in 2010?
Your response must be concise. 0.3. What is the ratio of the Electricity production(% of total) in Least developed countries in 2006 to that in 2010?
Keep it short and to the point. 0.74. What is the ratio of the Electricity production(% of total) of Costa Rica in 2006 to that in 2010?
Your answer should be compact. 1.03. What is the ratio of the Electricity production(% of total) of Lithuania in 2006 to that in 2010?
Your answer should be very brief. 0.04. What is the ratio of the Electricity production(% of total) in Central Europe in 2007 to that in 2008?
Give a very brief answer. 0.73. What is the ratio of the Electricity production(% of total) in Least developed countries in 2007 to that in 2008?
Your answer should be very brief. 0.92. What is the ratio of the Electricity production(% of total) of Costa Rica in 2007 to that in 2008?
Your response must be concise. 1.16. What is the ratio of the Electricity production(% of total) in Lithuania in 2007 to that in 2008?
Your response must be concise. 0.79. What is the ratio of the Electricity production(% of total) of Central Europe in 2007 to that in 2009?
Ensure brevity in your answer.  0.52. What is the ratio of the Electricity production(% of total) of Least developed countries in 2007 to that in 2009?
Your response must be concise. 0.79. What is the ratio of the Electricity production(% of total) in Costa Rica in 2007 to that in 2009?
Your answer should be very brief. 0.98. What is the ratio of the Electricity production(% of total) in Lithuania in 2007 to that in 2009?
Ensure brevity in your answer.  0.67. What is the ratio of the Electricity production(% of total) in Central Europe in 2007 to that in 2010?
Your answer should be very brief. 0.4. What is the ratio of the Electricity production(% of total) in Least developed countries in 2007 to that in 2010?
Your answer should be very brief. 0.63. What is the ratio of the Electricity production(% of total) in Costa Rica in 2007 to that in 2010?
Provide a succinct answer. 0.98. What is the ratio of the Electricity production(% of total) of Lithuania in 2007 to that in 2010?
Provide a short and direct response. 0.16. What is the ratio of the Electricity production(% of total) in Central Europe in 2008 to that in 2009?
Offer a very short reply. 0.71. What is the ratio of the Electricity production(% of total) in Least developed countries in 2008 to that in 2009?
Provide a short and direct response. 0.86. What is the ratio of the Electricity production(% of total) of Costa Rica in 2008 to that in 2009?
Provide a short and direct response. 0.85. What is the ratio of the Electricity production(% of total) in Lithuania in 2008 to that in 2009?
Make the answer very short. 0.85. What is the ratio of the Electricity production(% of total) of Central Europe in 2008 to that in 2010?
Provide a short and direct response. 0.55. What is the ratio of the Electricity production(% of total) of Least developed countries in 2008 to that in 2010?
Offer a terse response. 0.68. What is the ratio of the Electricity production(% of total) in Costa Rica in 2008 to that in 2010?
Ensure brevity in your answer.  0.85. What is the ratio of the Electricity production(% of total) of Lithuania in 2008 to that in 2010?
Your answer should be compact. 0.2. What is the ratio of the Electricity production(% of total) of Central Europe in 2009 to that in 2010?
Provide a short and direct response. 0.77. What is the ratio of the Electricity production(% of total) of Least developed countries in 2009 to that in 2010?
Your answer should be very brief. 0.8. What is the ratio of the Electricity production(% of total) in Lithuania in 2009 to that in 2010?
Keep it short and to the point. 0.24. What is the difference between the highest and the second highest Electricity production(% of total) in Central Europe?
Your response must be concise. 0.86. What is the difference between the highest and the second highest Electricity production(% of total) of Least developed countries?
Give a very brief answer. 0.02. What is the difference between the highest and the second highest Electricity production(% of total) in Costa Rica?
Make the answer very short. 0.12. What is the difference between the highest and the second highest Electricity production(% of total) in Lithuania?
Your answer should be compact. 5.65. What is the difference between the highest and the lowest Electricity production(% of total) in Central Europe?
Make the answer very short. 3.17. What is the difference between the highest and the lowest Electricity production(% of total) of Least developed countries?
Your answer should be very brief. 0.03. What is the difference between the highest and the lowest Electricity production(% of total) of Costa Rica?
Your answer should be compact. 3.2. What is the difference between the highest and the lowest Electricity production(% of total) in Lithuania?
Offer a terse response. 7.39. 